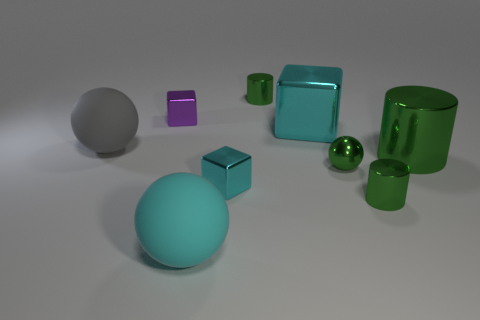Are there any tiny green shiny cylinders that are on the left side of the cube in front of the large matte ball behind the big green shiny object? The image depicts various geometric shapes with differing colors and textures. Upon careful observation, there don't appear to be any tiny green shiny cylinders to the left of the cube that is positioned in front of the large matte ball, and behind the big green shiny object. The scene is clear of such specific objects matching that detailed description. 